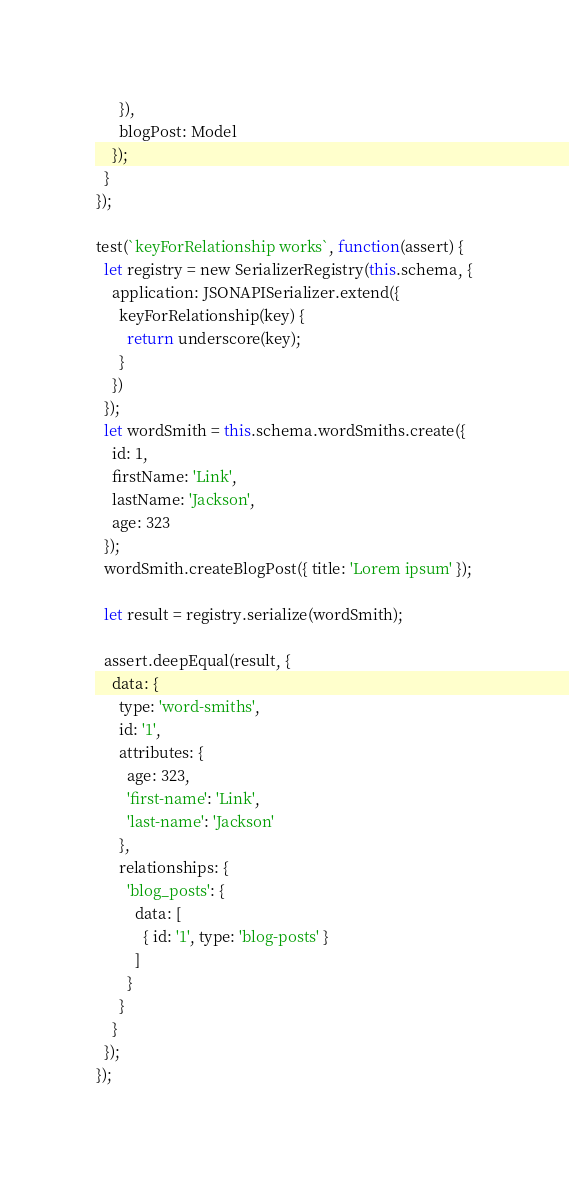<code> <loc_0><loc_0><loc_500><loc_500><_JavaScript_>      }),
      blogPost: Model
    });
  }
});

test(`keyForRelationship works`, function(assert) {
  let registry = new SerializerRegistry(this.schema, {
    application: JSONAPISerializer.extend({
      keyForRelationship(key) {
        return underscore(key);
      }
    })
  });
  let wordSmith = this.schema.wordSmiths.create({
    id: 1,
    firstName: 'Link',
    lastName: 'Jackson',
    age: 323
  });
  wordSmith.createBlogPost({ title: 'Lorem ipsum' });

  let result = registry.serialize(wordSmith);

  assert.deepEqual(result, {
    data: {
      type: 'word-smiths',
      id: '1',
      attributes: {
        age: 323,
        'first-name': 'Link',
        'last-name': 'Jackson'
      },
      relationships: {
        'blog_posts': {
          data: [
            { id: '1', type: 'blog-posts' }
          ]
        }
      }
    }
  });
});
</code> 